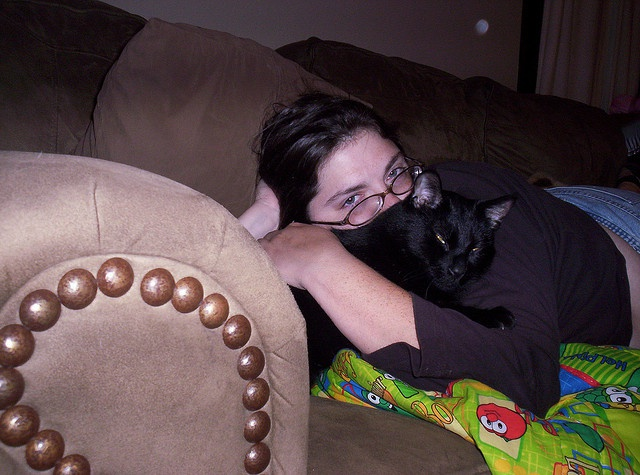Describe the objects in this image and their specific colors. I can see couch in black, gray, darkgray, and brown tones, people in black, lightpink, and gray tones, and cat in black, gray, and purple tones in this image. 